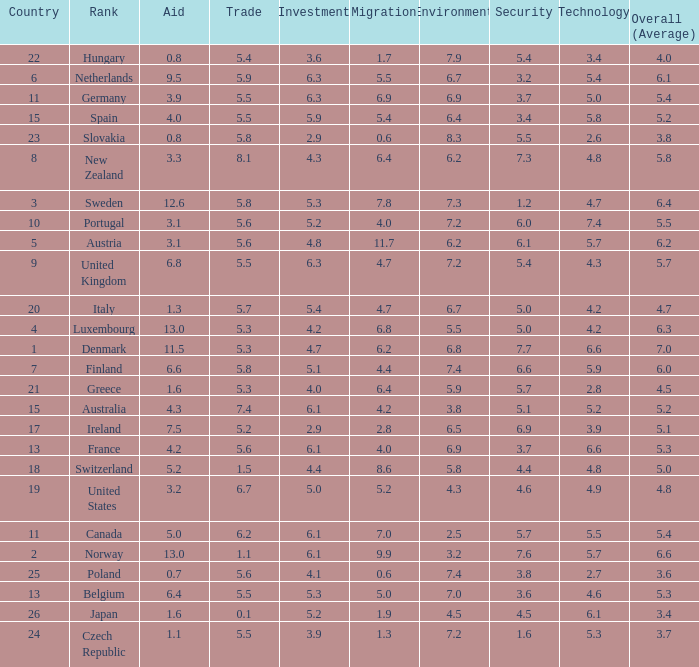What is the environment rating of the country with an overall average rating of 4.7? 6.7. 